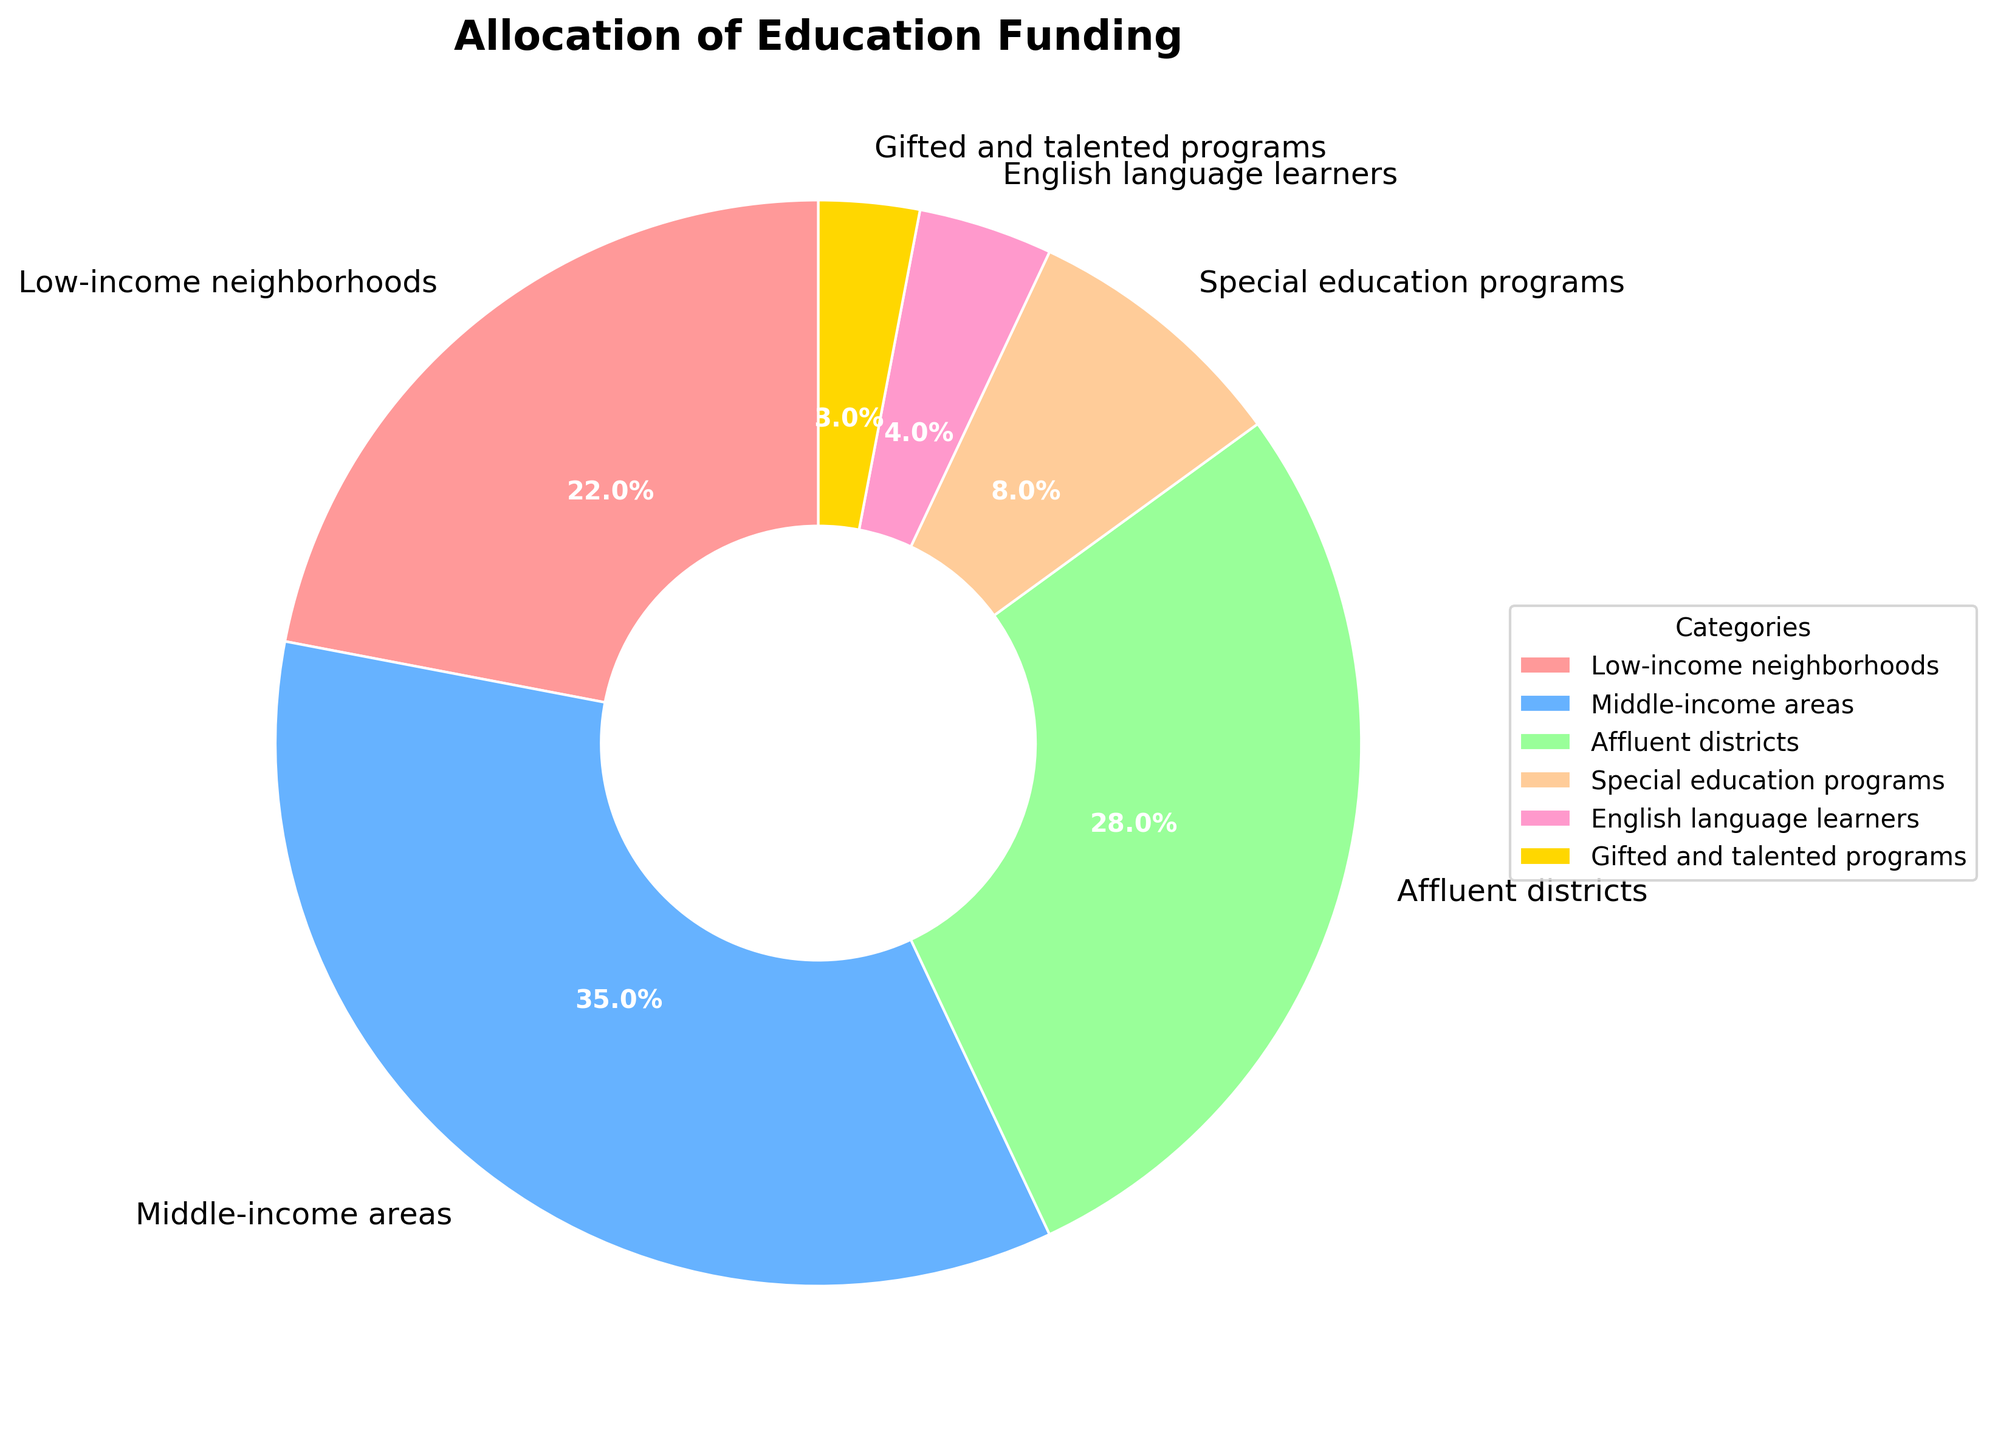What percentage of funding is allocated to low-income neighborhoods? By looking at the pie chart, we can identify the label for low-income neighborhoods and directly see the corresponding percentage.
Answer: 22% Which category receives the highest percentage of education funding? By comparing the percentage values of all categories visible on the pie chart, we can determine that the middle-income areas receive the highest percentage of funding.
Answer: Middle-income areas How does the percentage allocated to special education programs compare to the percentage for affluent districts? Comparing the two segments on the pie chart, special education programs receive 8% and affluent districts receive 28%.
Answer: Affluent districts receive 20% more funding than special education programs What is the combined percentage of funding allocated to both gifted and talented programs and English language learners? Adding the percentages for gifted and talented programs (3%) and English language learners (4%) from the pie chart, we get a total of 7%.
Answer: 7% Which two groups account for the smallest allocation of education funding? By observing the pie chart, the two smallest segments in terms of percentage are the ones labeled as gifted and talented programs and English language learners.
Answer: Gifted and talented programs, English language learners Is more funding allocated to special education programs or to low-income neighborhoods? Comparing the percentages from the pie chart, special education programs receive 8%, and low-income neighborhoods receive 22%.
Answer: Low-income neighborhoods receive more funding What is the visual color assigned to the category with the highest funding allocation? Observing the color associated with the middle-income areas segment on the pie chart, it is the blue wedge.
Answer: Blue Among the categories listed, which two receive nearly equal funding allocations, differing by just 1%? From the pie chart, comparing the percentages, affluent districts receive 28% and low-income neighborhoods receive 22%, having a 6% difference. On closer observation, no exact 1% difference is there, suggesting none from this set have a 1% difference.
Answer: None What's the difference in funding percentage between low-income neighborhoods and middle-income areas? Subtract the percentage of low-income neighborhoods (22%) from that of middle-income areas (35%) as seen on the pie chart: 35% - 22% = 13%.
Answer: 13% How many categories receive less than 10% of the funding? By counting the segments on the pie chart that are less than 10%, namely special education programs (8%), English language learners (4%), and gifted and talented programs (3%), there are three such categories.
Answer: 3 